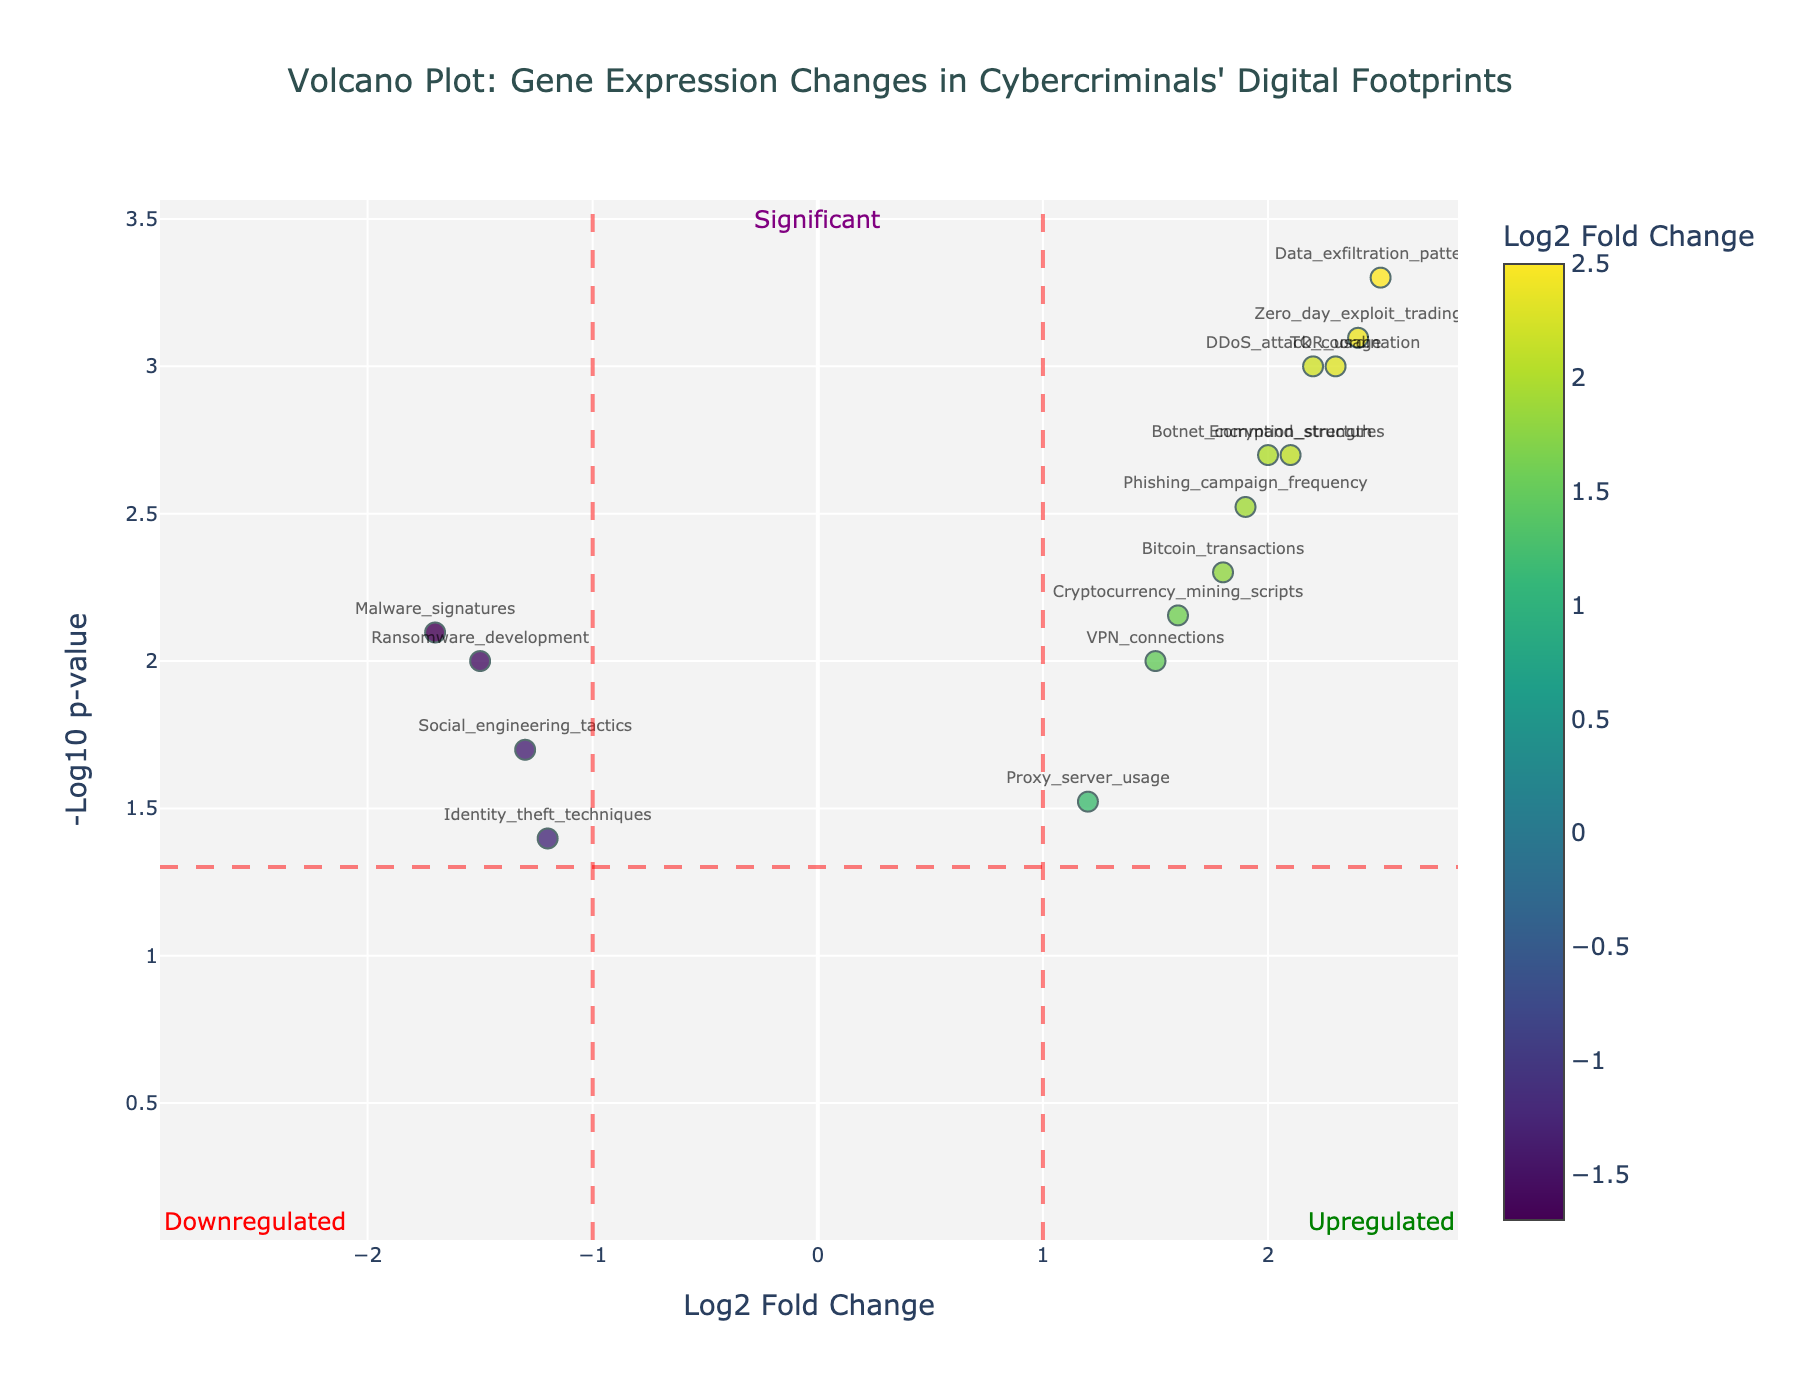How many data points are above the significance threshold line? To determine the number of data points above the significance threshold line, you need to count the markers that are above the reference line at -Log10(p-value) = 1.30
Answer: 10 Which gene expression exhibits the greatest upregulation? Upregulation can be identified by the highest positive log2 fold change. Among all data points, "Data_exfiltration_patterns" shows the highest log2 fold change of 2.5
Answer: Data_exfiltration_patterns Which gene expression exhibits the greatest downregulation? Downregulation can be identified by the most negative log2 fold change. "Malware_signatures" has the lowest log2 fold change of -1.7
Answer: Malware_signatures What is the p-value of the "Zero_day_exploit_trading"? By examining the hover text information for "Zero_day_exploit_trading," our interest is in the p-value provided. The p-value for this gene expression is 0.0008
Answer: 0.0008 How many gene expressions show a log2 fold change greater than 2? Assess the count of gene expressions with log2 fold changes higher than 2 by checking how many of these data points surpass the specified value
Answer: 5 Do any gene expressions with p-values less than 0.005 exhibit negative log2 fold changes? If so, which ones? To identify these, look for data points with a -Log10(p-value) higher than 2.3 and a negative log2 fold change. "Malware_signatures" satisfies both conditions
Answer: Malware_signatures Between "Bitcoin_transactions" and "DDoS_attack_coordination," which one has a more significant p-value? Compare the p-values of both expressions. "Bitcoin_transactions" has a p-value of 0.005, while "DDoS_attack_coordination" has one of 0.001, making the latter more significant
Answer: DDoS_attack_coordination What is the p-value corresponding to the significance threshold line on the Volcano plot? The significance threshold line is at -Log10(p-value) = 1.30, so converting it back to the p-value format, p = 10^(-1.30)
Answer: 0.05 Which gene expressions fall into the "Upregulated" category with significance? Markers to the right of the vertical line at log2 fold change = 1 and above the horizontal -Log10(p-value) = 1.30 line represent this group. These include "TOR_usage," "Bitcoin_transactions," "VPN_connections," "Encryption_strength," "Data_exfiltration_patterns," "Phishing_campaign_frequency," "DDoS_attack_coordination," "Cryptocurrency_mining_scripts," "Botnet_command_structures," and "Zero_day_exploit_trading"
Answer: 10 gene expressions 